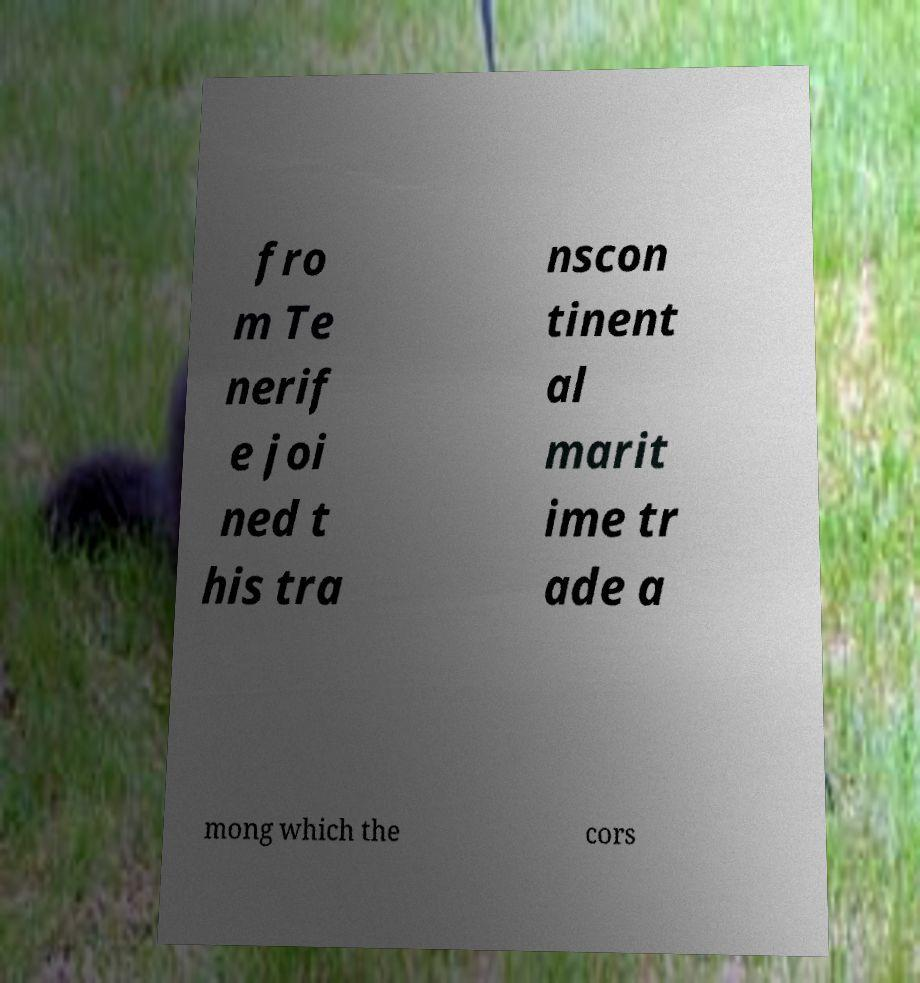Could you assist in decoding the text presented in this image and type it out clearly? fro m Te nerif e joi ned t his tra nscon tinent al marit ime tr ade a mong which the cors 